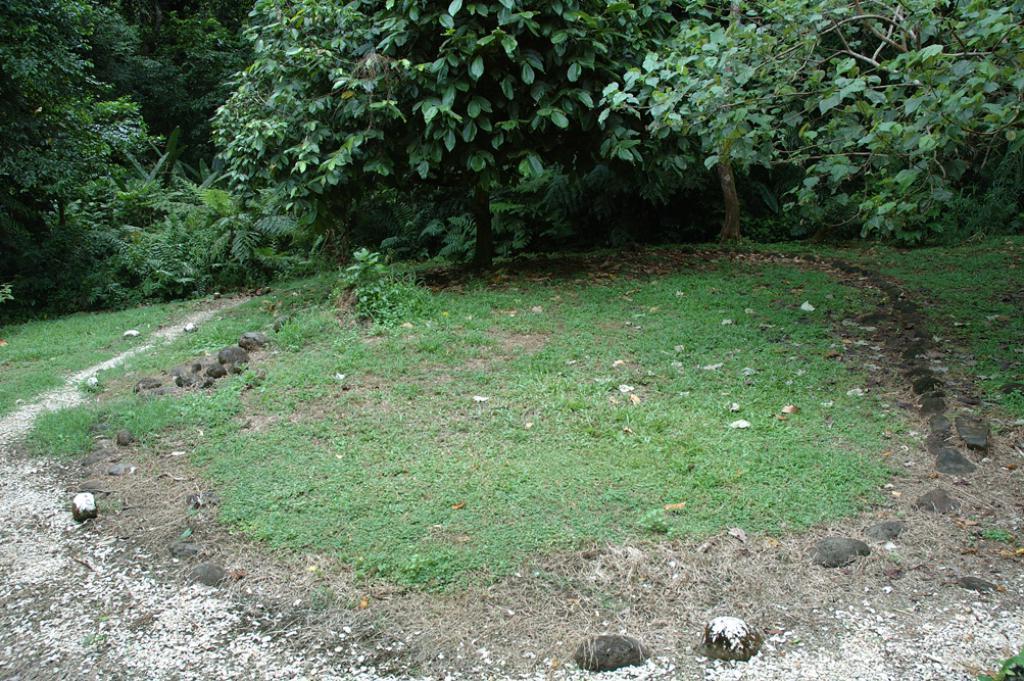Can you describe this image briefly? In this image at the bottom there are plants, grass, stones and land. At the top there are trees. 